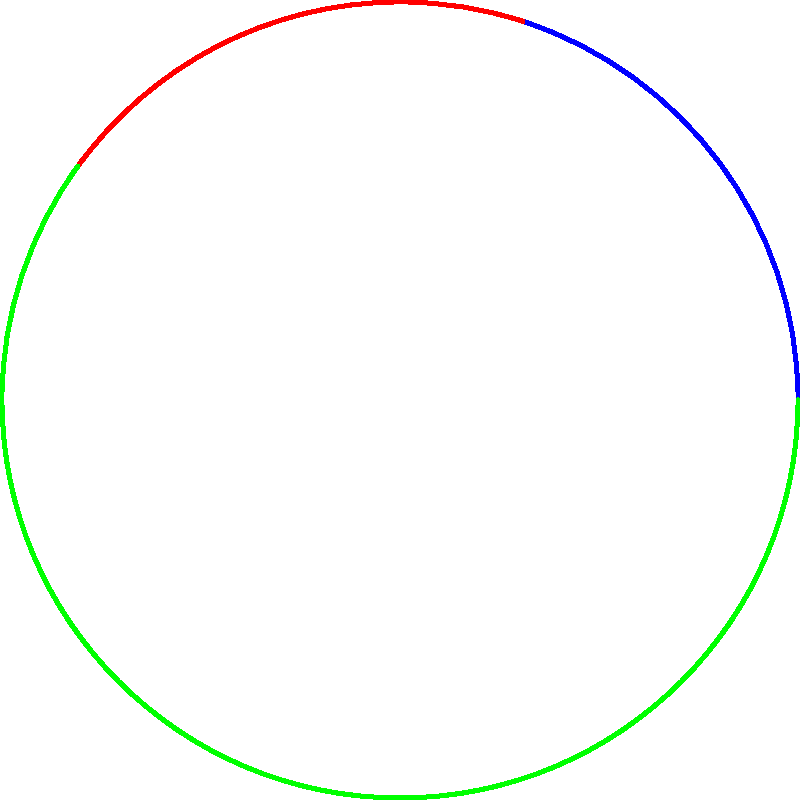In a literary analysis of marginalized voices in contemporary literature, a circular diagram represents the proportion of different groups. The blue sector represents LGBTQ+ authors (20%), the red sector represents authors of color (40%), and the green sector represents other marginalized voices (40%). If the total area of the circle is 900π cm², what is the area of the sector representing LGBTQ+ authors? To solve this problem, we'll follow these steps:

1) First, recall that the area of a circular sector is given by the formula:
   $$A_{sector} = \frac{\theta}{360°} \cdot \pi r^2$$
   where θ is the central angle in degrees and r is the radius of the circle.

2) We're given that the LGBTQ+ authors represent 20% of the total, which corresponds to a central angle of:
   $$\theta = 20\% \cdot 360° = 0.2 \cdot 360° = 72°$$

3) We're also given that the total area of the circle is 900π cm². We can use this to find the radius:
   $$A_{total} = \pi r^2 = 900\pi$$
   $$r^2 = 900$$
   $$r = 30 \text{ cm}$$

4) Now we can substitute these values into our sector area formula:
   $$A_{LGBTQ+} = \frac{72°}{360°} \cdot \pi (30\text{ cm})^2$$

5) Simplify:
   $$A_{LGBTQ+} = \frac{1}{5} \cdot \pi \cdot 900\text{ cm}^2 = 180\pi\text{ cm}^2$$

Therefore, the area of the sector representing LGBTQ+ authors is 180π cm².
Answer: 180π cm² 